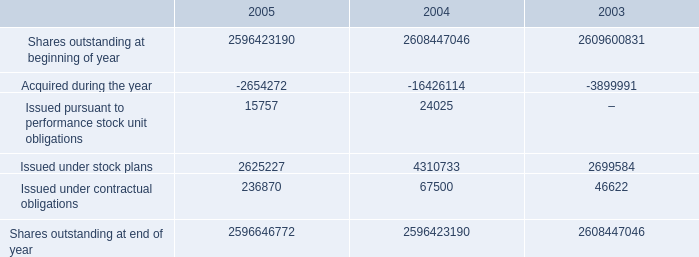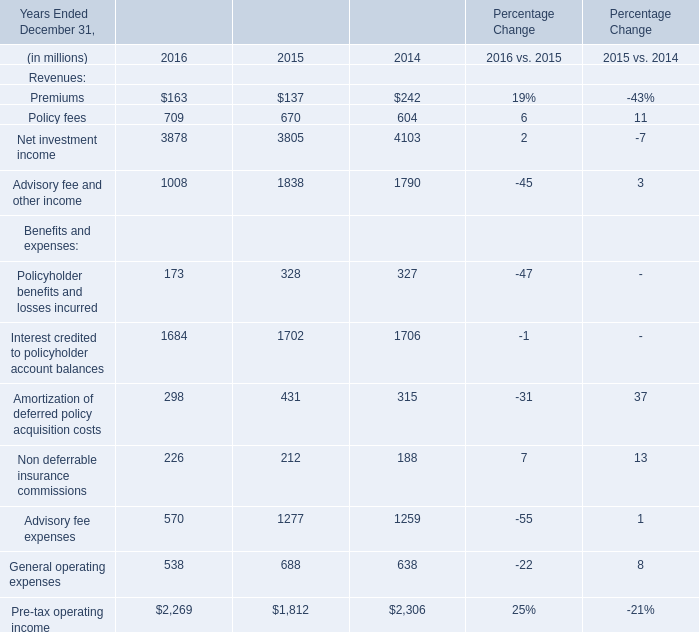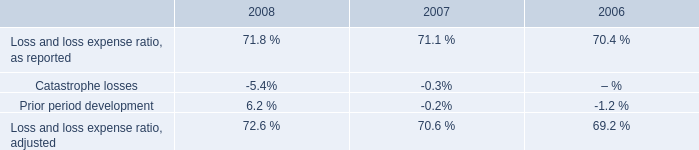What is the sum of Shares outstanding at end of year of 2005, and Net investment income of Percentage Change 2014 ? 
Computations: (2596646772.0 + 4103.0)
Answer: 2596650875.0. 